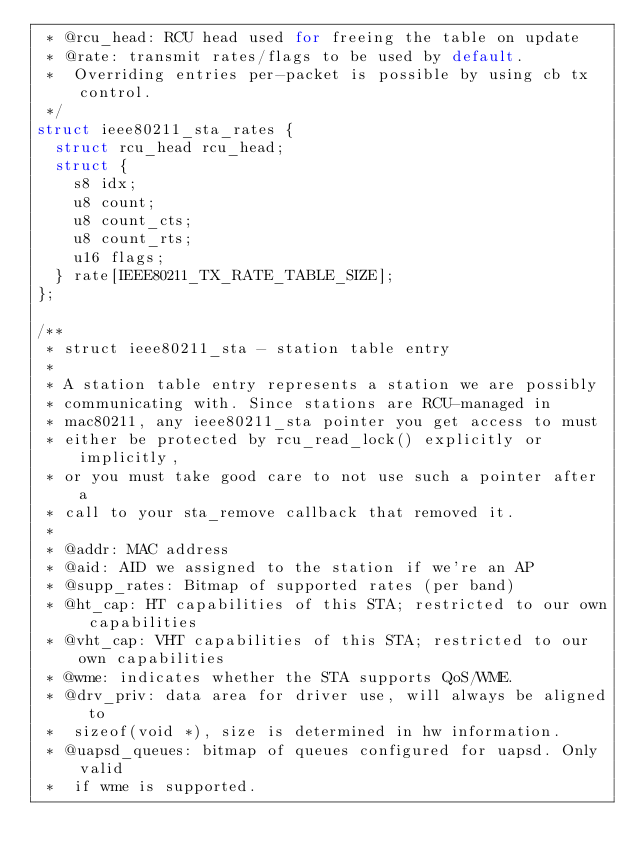Convert code to text. <code><loc_0><loc_0><loc_500><loc_500><_C_> * @rcu_head: RCU head used for freeing the table on update
 * @rate: transmit rates/flags to be used by default.
 *	Overriding entries per-packet is possible by using cb tx control.
 */
struct ieee80211_sta_rates {
	struct rcu_head rcu_head;
	struct {
		s8 idx;
		u8 count;
		u8 count_cts;
		u8 count_rts;
		u16 flags;
	} rate[IEEE80211_TX_RATE_TABLE_SIZE];
};

/**
 * struct ieee80211_sta - station table entry
 *
 * A station table entry represents a station we are possibly
 * communicating with. Since stations are RCU-managed in
 * mac80211, any ieee80211_sta pointer you get access to must
 * either be protected by rcu_read_lock() explicitly or implicitly,
 * or you must take good care to not use such a pointer after a
 * call to your sta_remove callback that removed it.
 *
 * @addr: MAC address
 * @aid: AID we assigned to the station if we're an AP
 * @supp_rates: Bitmap of supported rates (per band)
 * @ht_cap: HT capabilities of this STA; restricted to our own capabilities
 * @vht_cap: VHT capabilities of this STA; restricted to our own capabilities
 * @wme: indicates whether the STA supports QoS/WME.
 * @drv_priv: data area for driver use, will always be aligned to
 *	sizeof(void *), size is determined in hw information.
 * @uapsd_queues: bitmap of queues configured for uapsd. Only valid
 *	if wme is supported.</code> 